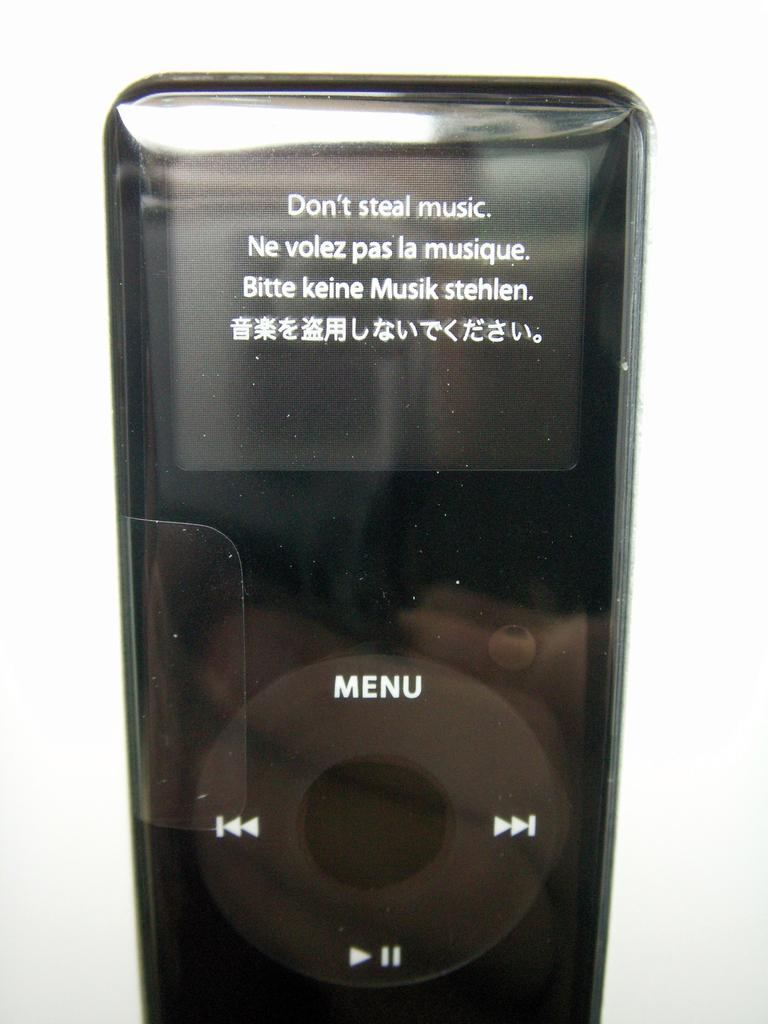<image>
Summarize the visual content of the image. A black Apple iPod says Don't Steal Music. 